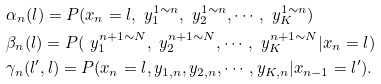<formula> <loc_0><loc_0><loc_500><loc_500>& \alpha _ { n } ( l ) = P ( x _ { n } = l , \ y _ { 1 } ^ { 1 \sim n } , \ y _ { 2 } ^ { 1 \sim n } , \cdots , \ y _ { K } ^ { 1 \sim n } ) \\ & \beta _ { n } ( l ) = P ( \ y _ { 1 } ^ { n + 1 \sim N } , \ y _ { 2 } ^ { n + 1 \sim N } , \cdots , \ y _ { K } ^ { n + 1 \sim N } | x _ { n } = l ) \\ & \gamma _ { n } ( l ^ { \prime } , l ) = P ( x _ { n } = l , y _ { 1 , n } , y _ { 2 , n } , \cdots , y _ { K , n } | x _ { n - 1 } = l ^ { \prime } ) .</formula> 